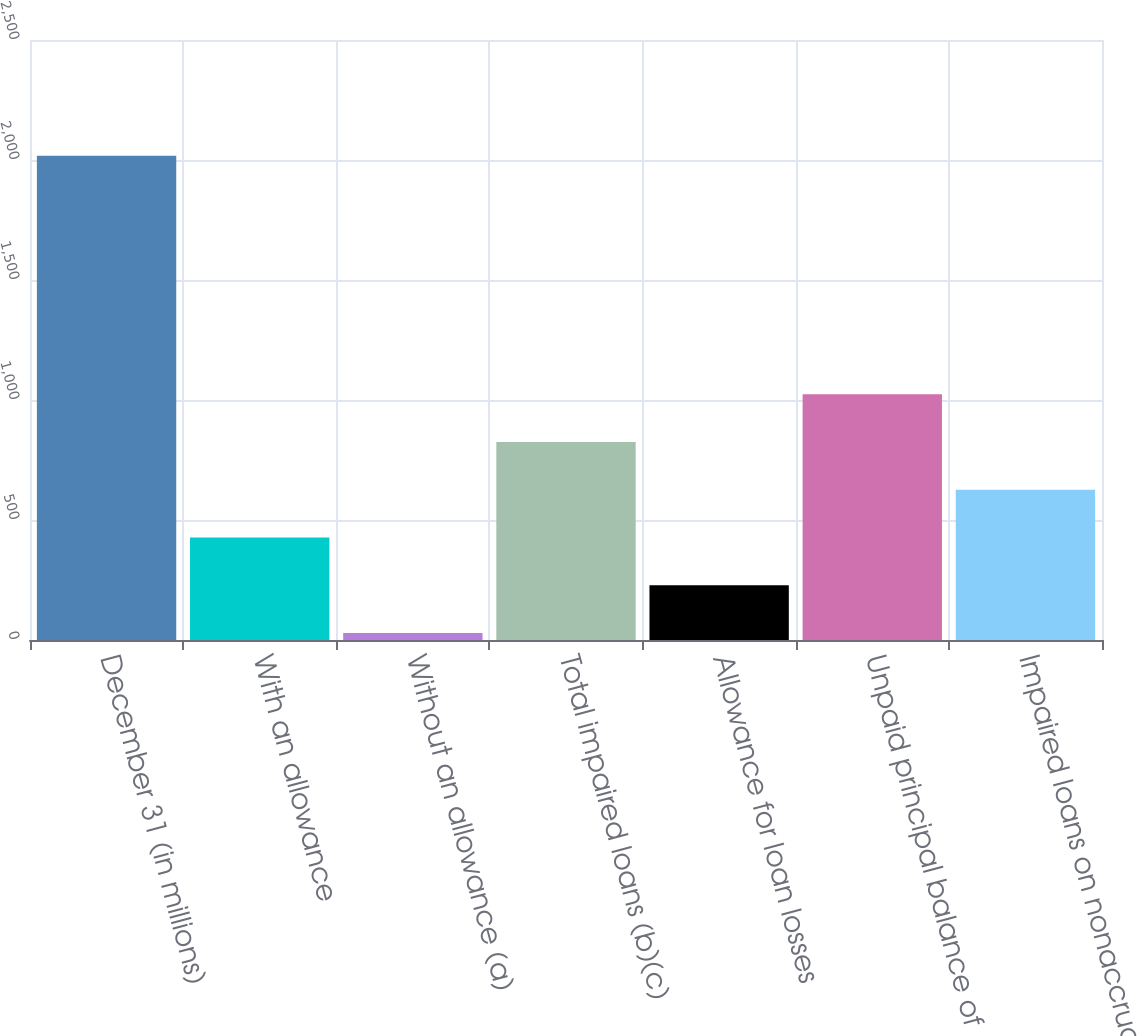Convert chart to OTSL. <chart><loc_0><loc_0><loc_500><loc_500><bar_chart><fcel>December 31 (in millions)<fcel>With an allowance<fcel>Without an allowance (a)<fcel>Total impaired loans (b)(c)<fcel>Allowance for loan losses<fcel>Unpaid principal balance of<fcel>Impaired loans on nonaccrual<nl><fcel>2018<fcel>426.8<fcel>29<fcel>824.6<fcel>227.9<fcel>1023.5<fcel>625.7<nl></chart> 